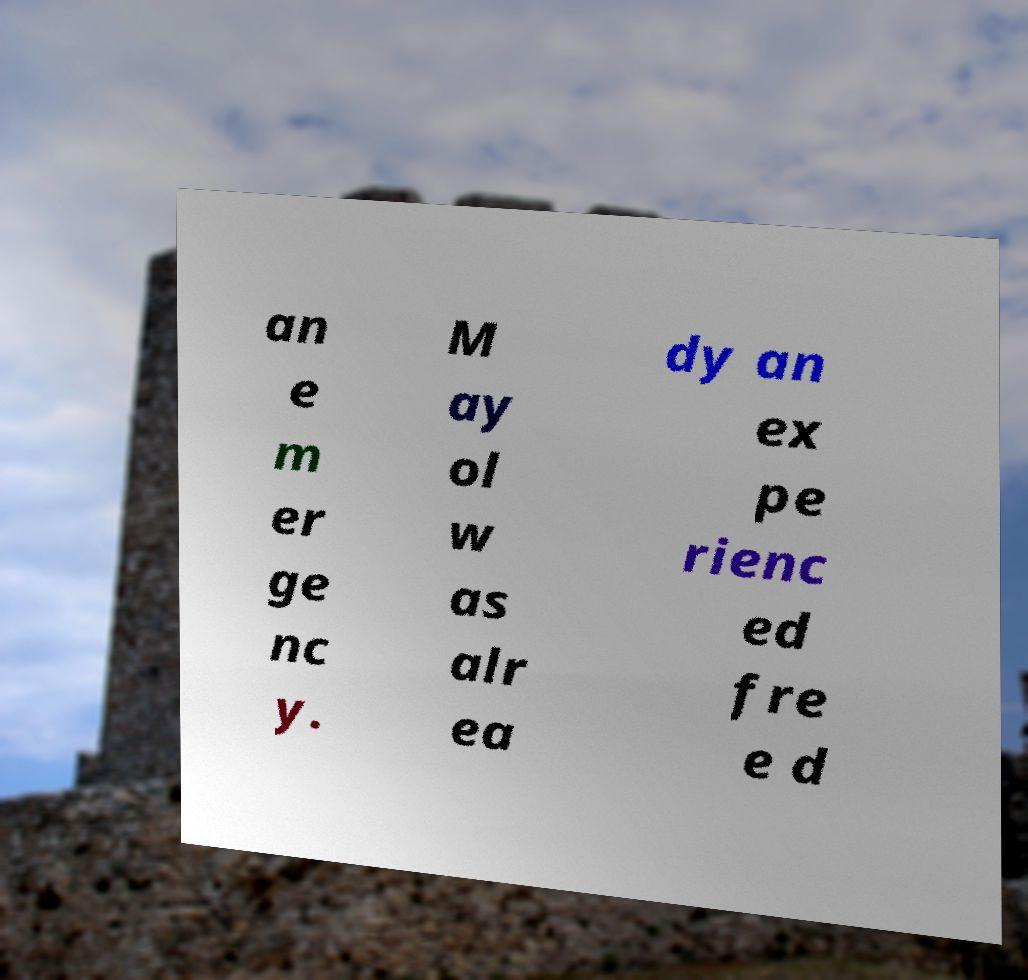Can you accurately transcribe the text from the provided image for me? an e m er ge nc y. M ay ol w as alr ea dy an ex pe rienc ed fre e d 